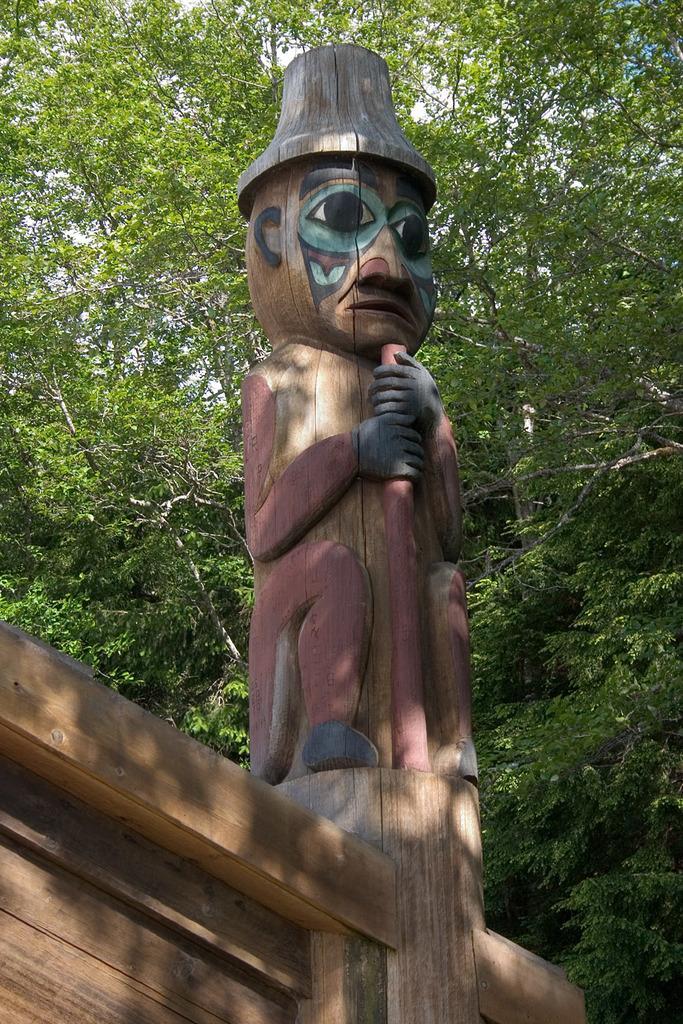Describe this image in one or two sentences. In this picture we can see a wooden sculpture and behind the sculpture there are trees and a sky. 